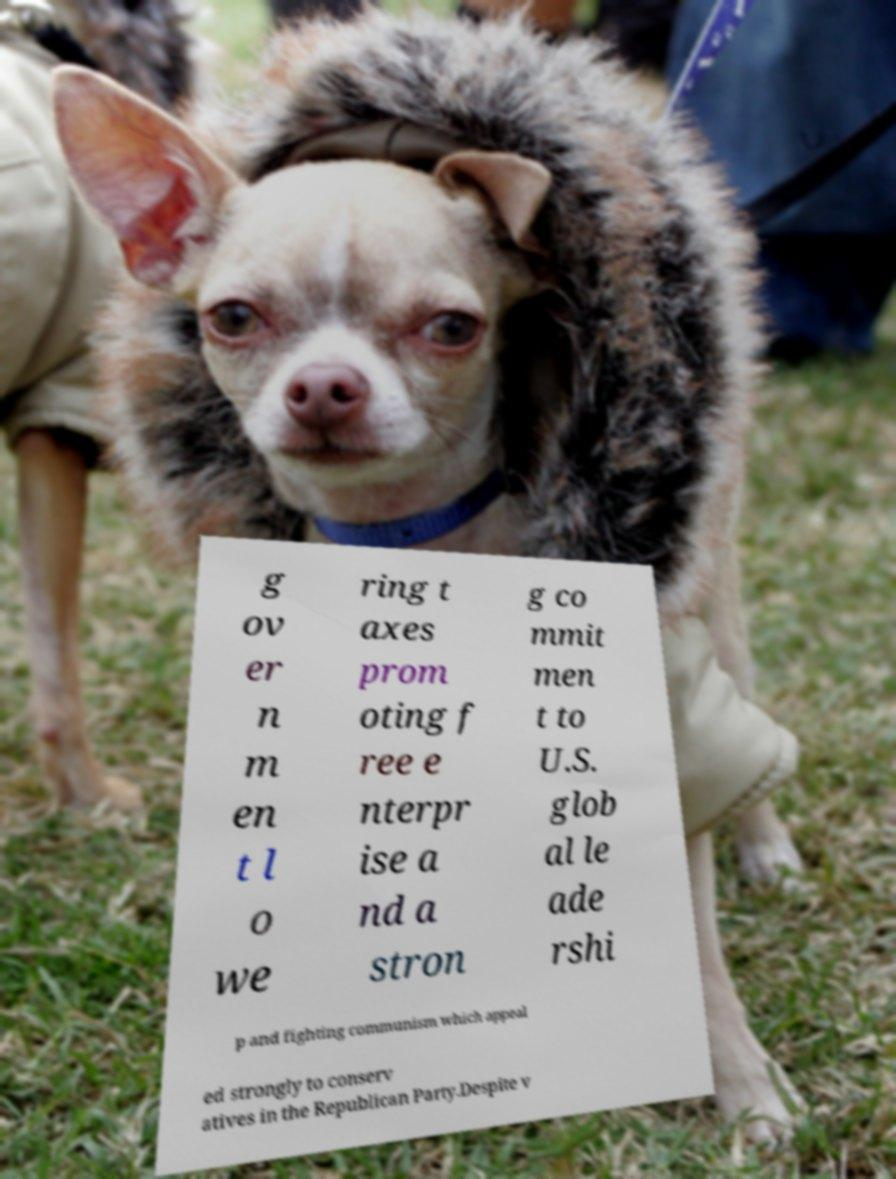I need the written content from this picture converted into text. Can you do that? g ov er n m en t l o we ring t axes prom oting f ree e nterpr ise a nd a stron g co mmit men t to U.S. glob al le ade rshi p and fighting communism which appeal ed strongly to conserv atives in the Republican Party.Despite v 